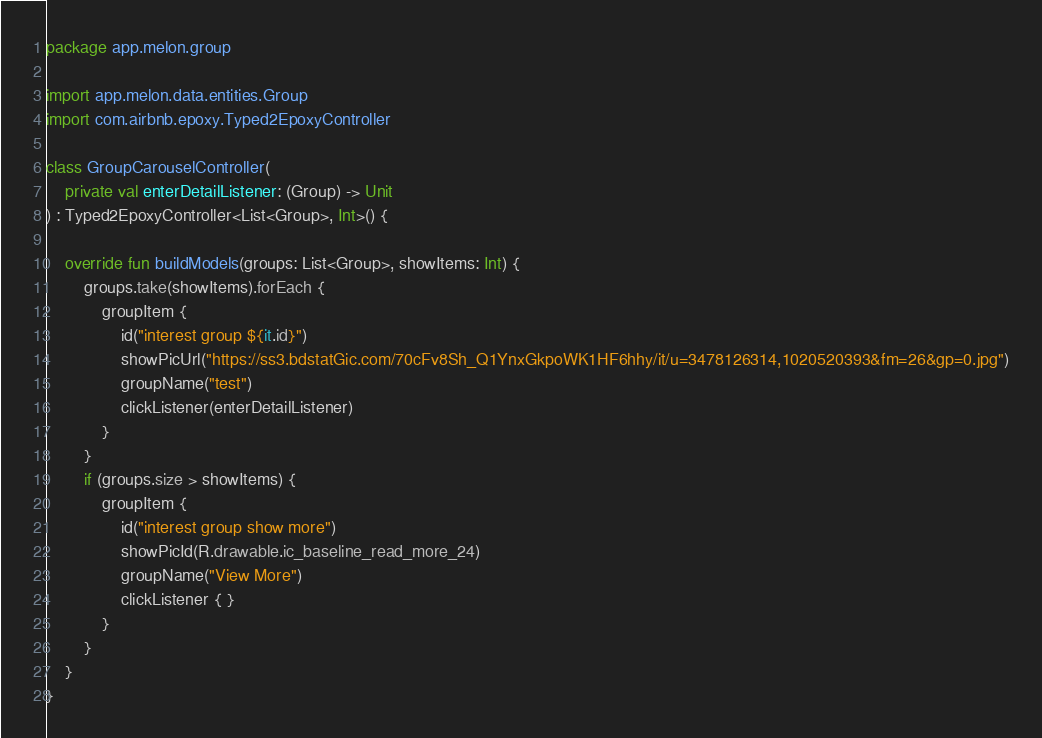<code> <loc_0><loc_0><loc_500><loc_500><_Kotlin_>package app.melon.group

import app.melon.data.entities.Group
import com.airbnb.epoxy.Typed2EpoxyController

class GroupCarouselController(
    private val enterDetailListener: (Group) -> Unit
) : Typed2EpoxyController<List<Group>, Int>() {

    override fun buildModels(groups: List<Group>, showItems: Int) {
        groups.take(showItems).forEach {
            groupItem {
                id("interest group ${it.id}")
                showPicUrl("https://ss3.bdstatGic.com/70cFv8Sh_Q1YnxGkpoWK1HF6hhy/it/u=3478126314,1020520393&fm=26&gp=0.jpg")
                groupName("test")
                clickListener(enterDetailListener)
            }
        }
        if (groups.size > showItems) {
            groupItem {
                id("interest group show more")
                showPicId(R.drawable.ic_baseline_read_more_24)
                groupName("View More")
                clickListener { }
            }
        }
    }
}</code> 